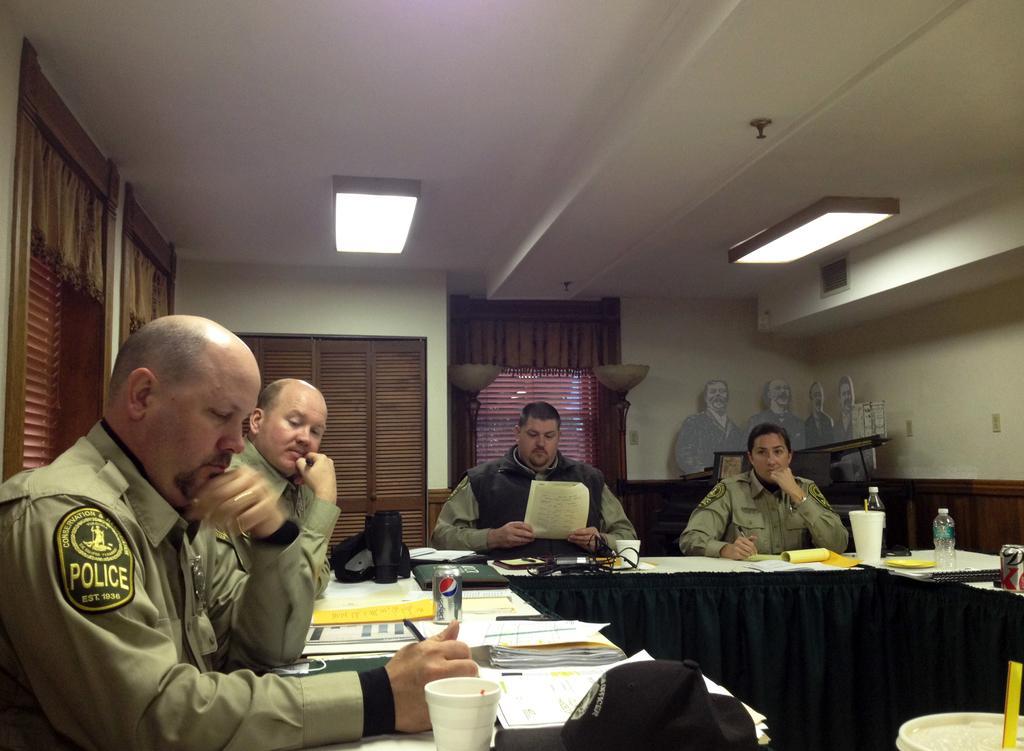Can you describe this image briefly? There are three men and a woman in the room. The man to the left corner is holding a pen and writing and the man beside him is looking at his writings. The woman to the right corner is also holding a pen but she is not writing. The man beside to her is looking at a paper. There is a table. On the table there are papers, filed, bottles, tin, cable wires and glasses too. There are two tube lights to the ceiling. There are some cupboards in the background attached to the wall. Behind woman there is a sheet of four men.  